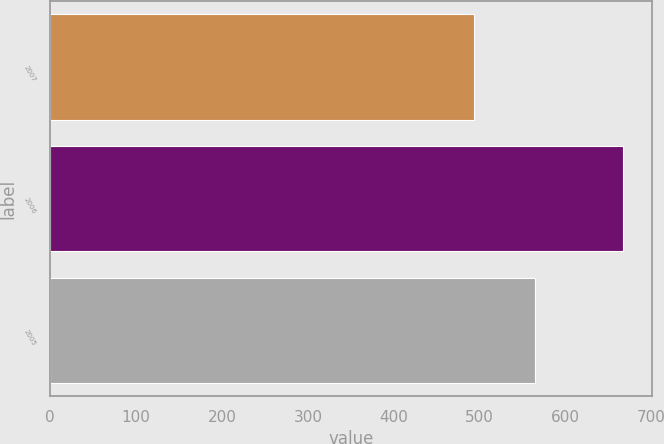Convert chart to OTSL. <chart><loc_0><loc_0><loc_500><loc_500><bar_chart><fcel>2007<fcel>2006<fcel>2005<nl><fcel>493<fcel>667.4<fcel>564.6<nl></chart> 